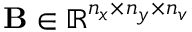<formula> <loc_0><loc_0><loc_500><loc_500>B \in \mathbb { R } ^ { n _ { x } \times n _ { y } \times n _ { v } }</formula> 